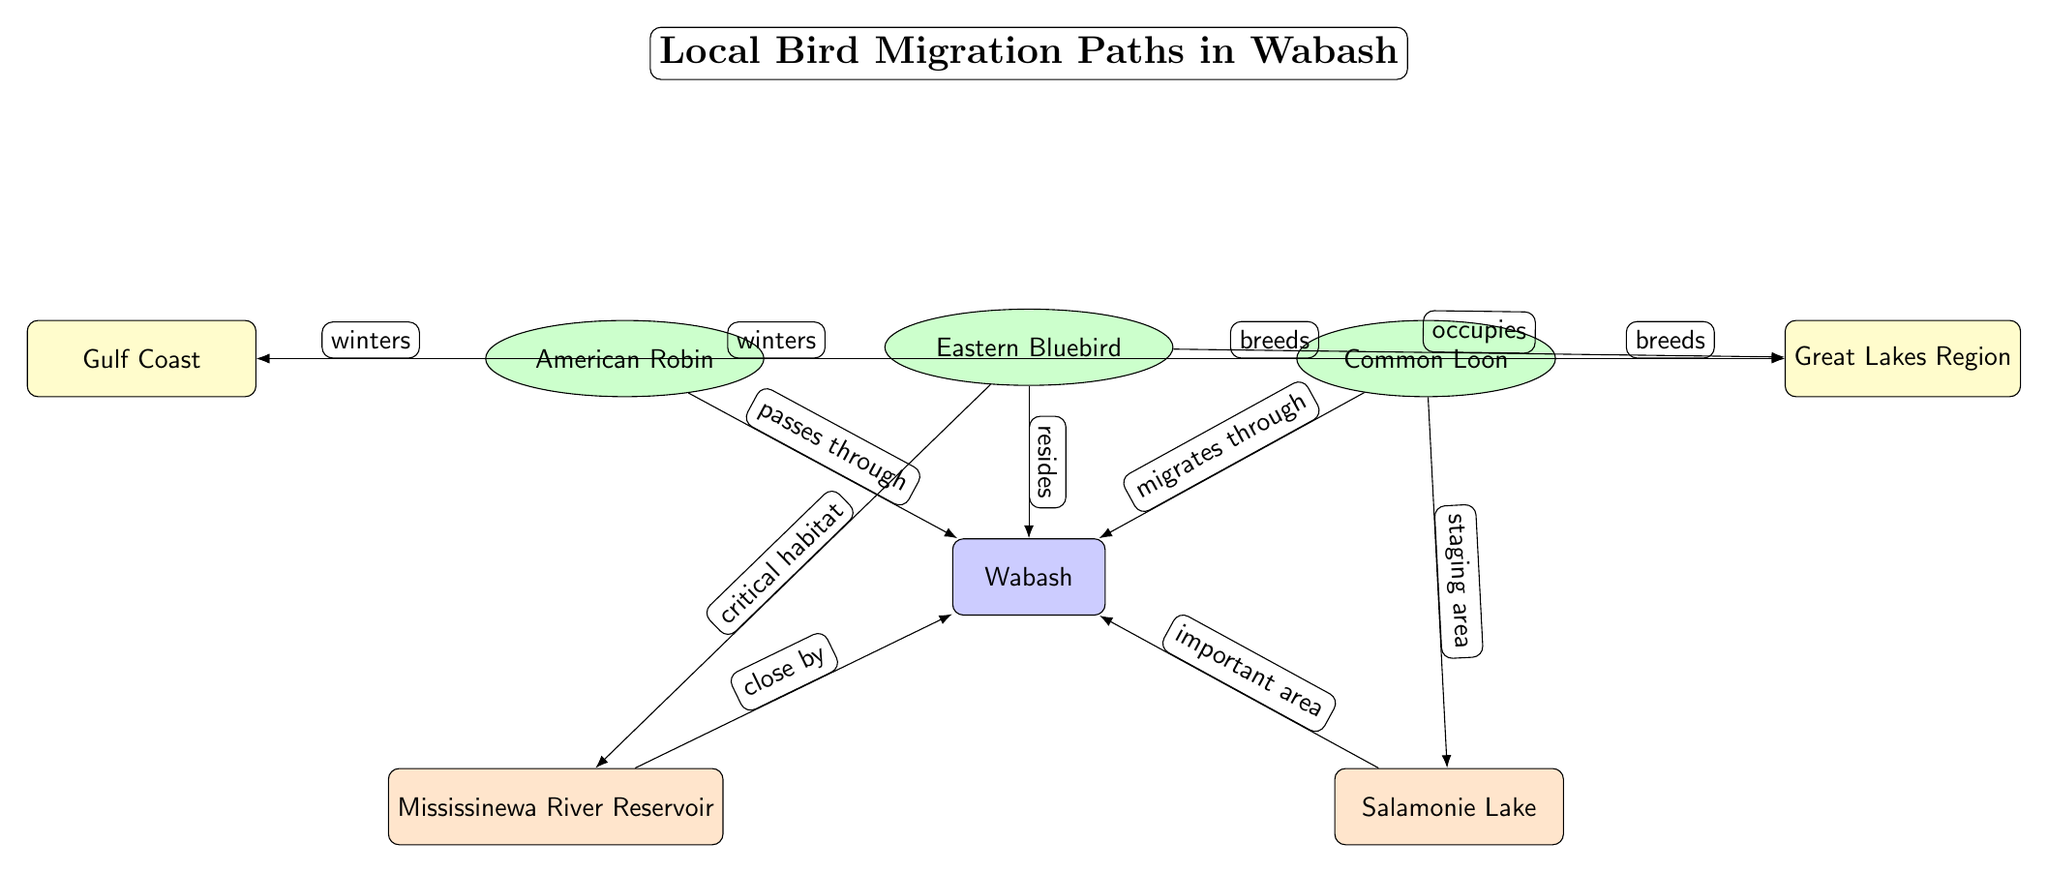What is the main title of the diagram? The title is positioned above the central node representing Wabash, indicated in the diagram as "Local Bird Migration Paths in Wabash."
Answer: Local Bird Migration Paths in Wabash How many bird species are represented in the diagram? There are three species nodes connected to Wabash: American Robin, Eastern Bluebird, and Common Loon, indicating that there are three bird species represented.
Answer: 3 Which bird species is shown to reside in Wabash? The diagram indicates that the Eastern Bluebird is connected directly to Wabash with the relationship "resides," indicating it is the species that resides there.
Answer: Eastern Bluebird Where do the Common Loon and American Robin breed according to the diagram? Both species (Common Loon and American Robin) have edges connected to the Great Lakes Region, which is identified as their breeding grounds in the diagram.
Answer: Great Lakes Region What relationship does the American Robin have with the Gulf Coast in the diagram? The American Robin is shown to "winter" in the Gulf Coast, indicating its migratory relationship with this area during winter months.
Answer: winters Which critical habitat is associated with the Eastern Bluebird in the diagram? The diagram shows an edge from the Eastern Bluebird to Mississinewa River Reservoir marked "critical habitat," indicating this habitat is essential for the Eastern Bluebird.
Answer: Mississinewa River Reservoir Which two habitats are highlighted as critical for the birds in Wabash? The diagram lists two critical habitats: Mississinewa River Reservoir and Salamonie Lake, showcasing their importance for local birds.
Answer: Mississinewa River Reservoir, Salamonie Lake What type of edge connects the Common Loon to Wabash? The Common Loon has the relationship "migrates through" with Wabash as indicated by the edge connecting these two nodes.
Answer: migrates through How does the migration pattern of the Common Loon differ from that of the Eastern Bluebird based on the diagram? The Common Loon is indicated to migrate through Wabash, while the Eastern Bluebird is shown to reside there, demonstrating that the Common Loon passes through during migration while the Eastern Bluebird makes it home in Wabash.
Answer: migrates through; resides 